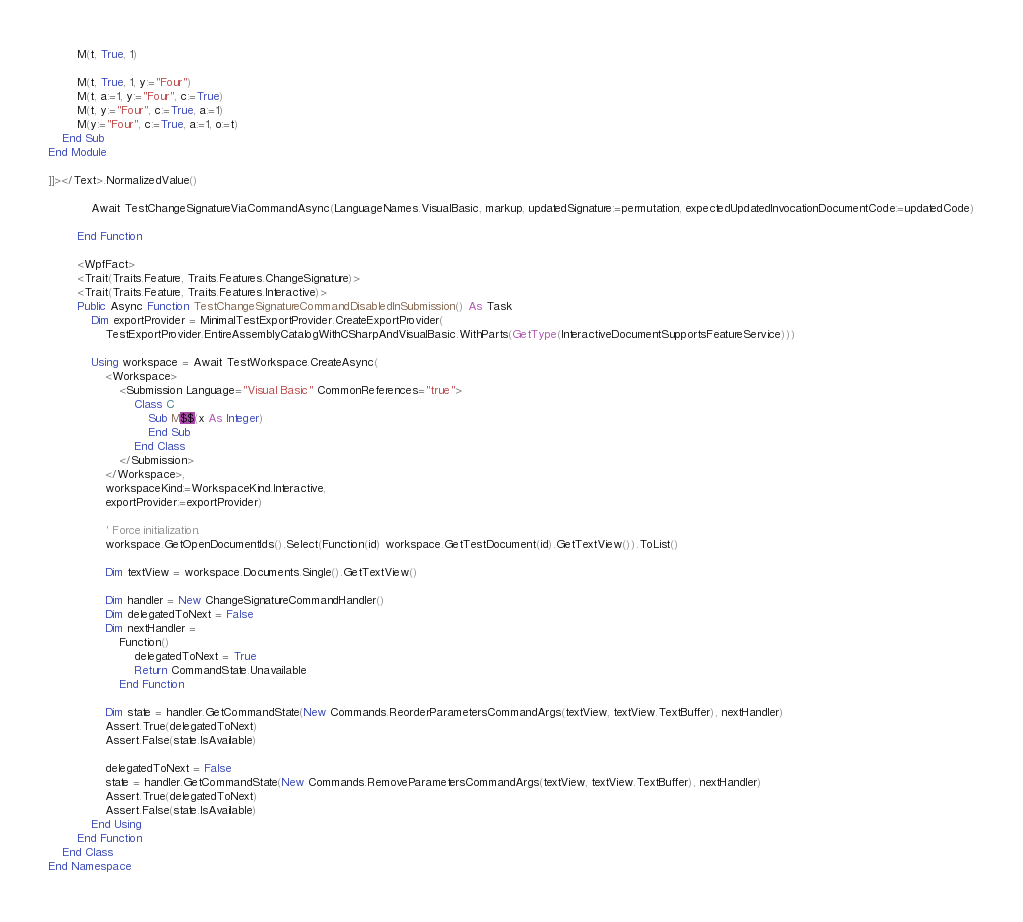Convert code to text. <code><loc_0><loc_0><loc_500><loc_500><_VisualBasic_>        M(t, True, 1)

        M(t, True, 1, y:="Four")
        M(t, a:=1, y:="Four", c:=True)
        M(t, y:="Four", c:=True, a:=1)
        M(y:="Four", c:=True, a:=1, o:=t)
    End Sub
End Module

]]></Text>.NormalizedValue()

            Await TestChangeSignatureViaCommandAsync(LanguageNames.VisualBasic, markup, updatedSignature:=permutation, expectedUpdatedInvocationDocumentCode:=updatedCode)

        End Function

        <WpfFact>
        <Trait(Traits.Feature, Traits.Features.ChangeSignature)>
        <Trait(Traits.Feature, Traits.Features.Interactive)>
        Public Async Function TestChangeSignatureCommandDisabledInSubmission() As Task
            Dim exportProvider = MinimalTestExportProvider.CreateExportProvider(
                TestExportProvider.EntireAssemblyCatalogWithCSharpAndVisualBasic.WithParts(GetType(InteractiveDocumentSupportsFeatureService)))

            Using workspace = Await TestWorkspace.CreateAsync(
                <Workspace>
                    <Submission Language="Visual Basic" CommonReferences="true">  
                        Class C
                            Sub M$$(x As Integer)
                            End Sub
                        End Class
                    </Submission>
                </Workspace>,
                workspaceKind:=WorkspaceKind.Interactive,
                exportProvider:=exportProvider)

                ' Force initialization.
                workspace.GetOpenDocumentIds().Select(Function(id) workspace.GetTestDocument(id).GetTextView()).ToList()

                Dim textView = workspace.Documents.Single().GetTextView()

                Dim handler = New ChangeSignatureCommandHandler()
                Dim delegatedToNext = False
                Dim nextHandler =
                    Function()
                        delegatedToNext = True
                        Return CommandState.Unavailable
                    End Function

                Dim state = handler.GetCommandState(New Commands.ReorderParametersCommandArgs(textView, textView.TextBuffer), nextHandler)
                Assert.True(delegatedToNext)
                Assert.False(state.IsAvailable)

                delegatedToNext = False
                state = handler.GetCommandState(New Commands.RemoveParametersCommandArgs(textView, textView.TextBuffer), nextHandler)
                Assert.True(delegatedToNext)
                Assert.False(state.IsAvailable)
            End Using
        End Function
    End Class
End Namespace</code> 